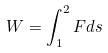<formula> <loc_0><loc_0><loc_500><loc_500>W = \int _ { 1 } ^ { 2 } F d s</formula> 